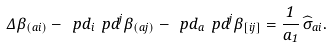Convert formula to latex. <formula><loc_0><loc_0><loc_500><loc_500>\Delta \beta _ { ( a i ) } - \ p d _ { i } \ p d ^ { j } \beta _ { ( a j ) } - \ p d _ { a } \ p d ^ { j } \beta _ { [ i j ] } = \frac { 1 } { a _ { 1 } } \, \widehat { \sigma } _ { a i } .</formula> 